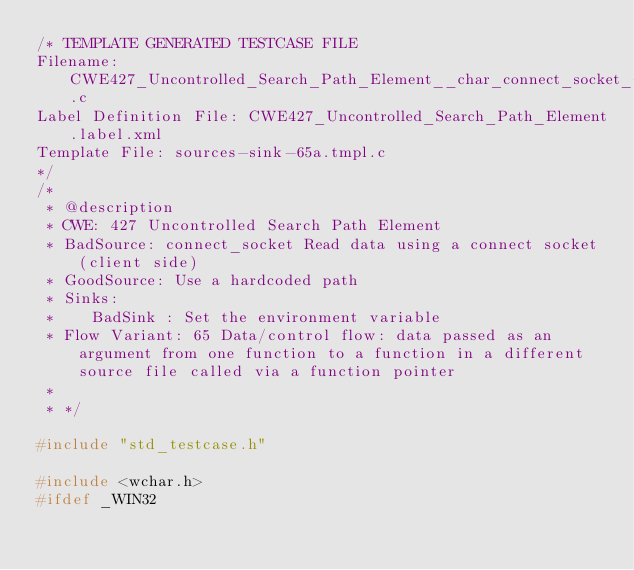<code> <loc_0><loc_0><loc_500><loc_500><_C_>/* TEMPLATE GENERATED TESTCASE FILE
Filename: CWE427_Uncontrolled_Search_Path_Element__char_connect_socket_65a.c
Label Definition File: CWE427_Uncontrolled_Search_Path_Element.label.xml
Template File: sources-sink-65a.tmpl.c
*/
/*
 * @description
 * CWE: 427 Uncontrolled Search Path Element
 * BadSource: connect_socket Read data using a connect socket (client side)
 * GoodSource: Use a hardcoded path
 * Sinks:
 *    BadSink : Set the environment variable
 * Flow Variant: 65 Data/control flow: data passed as an argument from one function to a function in a different source file called via a function pointer
 *
 * */

#include "std_testcase.h"

#include <wchar.h>
#ifdef _WIN32</code> 